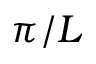Convert formula to latex. <formula><loc_0><loc_0><loc_500><loc_500>\pi / L</formula> 